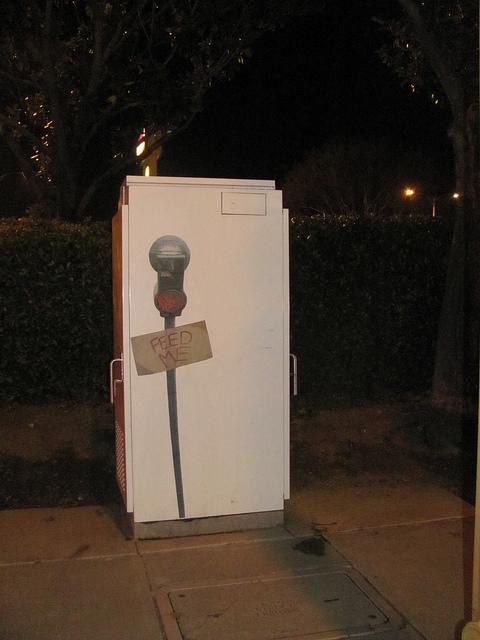Is it daytime in the photo?
Write a very short answer. No. What is the large white object?
Give a very brief answer. Refrigerator. Is the appliance in this picture broken?
Keep it brief. Yes. What object is on the ground in the front of this photograph?
Give a very brief answer. Box. What is hanging in front of the white wall?
Quick response, please. Sign. 